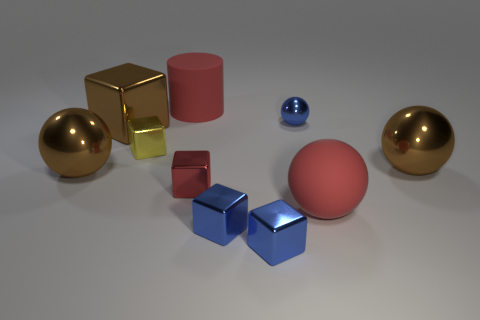How many brown balls must be subtracted to get 1 brown balls? 1 Subtract all large red rubber balls. How many balls are left? 3 Subtract all blue blocks. How many brown spheres are left? 2 Subtract all cylinders. How many objects are left? 9 Subtract 4 balls. How many balls are left? 0 Subtract all blue cubes. How many cubes are left? 3 Add 7 big cylinders. How many big cylinders are left? 8 Add 8 green matte cubes. How many green matte cubes exist? 8 Subtract 0 gray cylinders. How many objects are left? 10 Subtract all brown blocks. Subtract all yellow balls. How many blocks are left? 4 